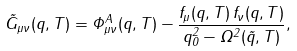<formula> <loc_0><loc_0><loc_500><loc_500>\tilde { G } _ { \mu \nu } ( q , T ) = \Phi ^ { A } _ { \mu \nu } ( q , T ) - \frac { f _ { \mu } ( q , T ) \, f _ { \nu } ( q , T ) } { q _ { 0 } ^ { 2 } - \Omega ^ { 2 } ( \vec { q } , T ) } ,</formula> 